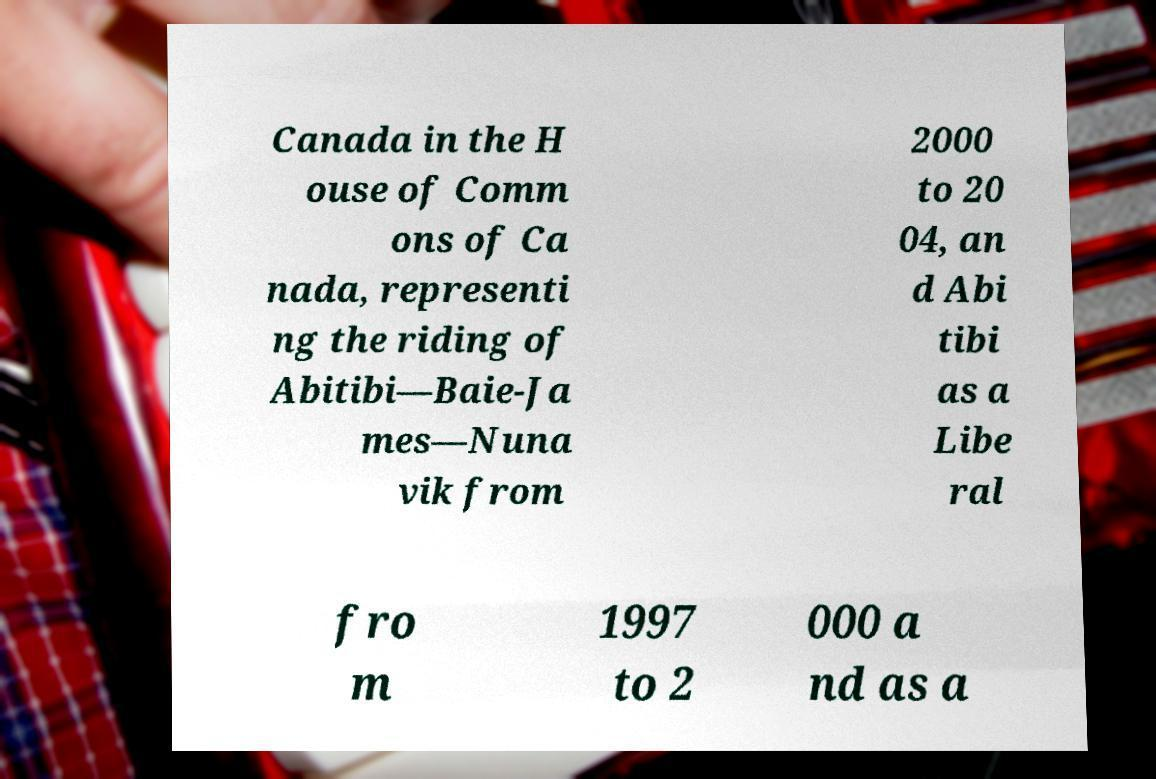For documentation purposes, I need the text within this image transcribed. Could you provide that? Canada in the H ouse of Comm ons of Ca nada, representi ng the riding of Abitibi—Baie-Ja mes—Nuna vik from 2000 to 20 04, an d Abi tibi as a Libe ral fro m 1997 to 2 000 a nd as a 